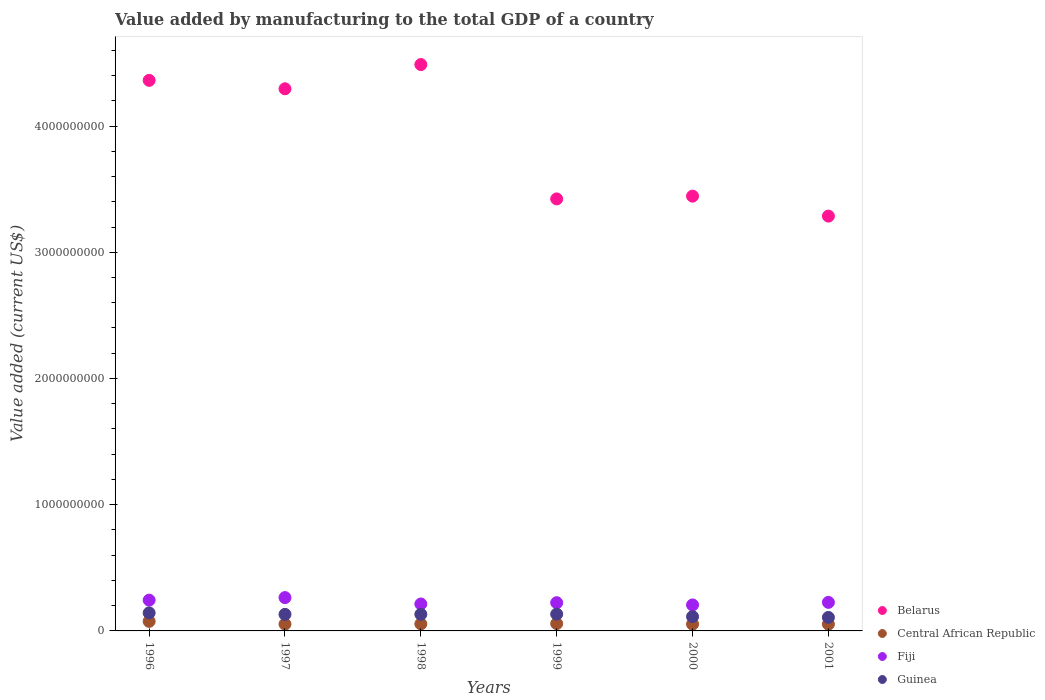Is the number of dotlines equal to the number of legend labels?
Keep it short and to the point. Yes. What is the value added by manufacturing to the total GDP in Guinea in 1998?
Offer a terse response. 1.32e+08. Across all years, what is the maximum value added by manufacturing to the total GDP in Central African Republic?
Your answer should be compact. 7.56e+07. Across all years, what is the minimum value added by manufacturing to the total GDP in Guinea?
Provide a succinct answer. 1.07e+08. What is the total value added by manufacturing to the total GDP in Central African Republic in the graph?
Offer a terse response. 3.50e+08. What is the difference between the value added by manufacturing to the total GDP in Fiji in 2000 and that in 2001?
Offer a terse response. -2.03e+07. What is the difference between the value added by manufacturing to the total GDP in Central African Republic in 1997 and the value added by manufacturing to the total GDP in Fiji in 1996?
Make the answer very short. -1.90e+08. What is the average value added by manufacturing to the total GDP in Belarus per year?
Make the answer very short. 3.88e+09. In the year 1998, what is the difference between the value added by manufacturing to the total GDP in Fiji and value added by manufacturing to the total GDP in Guinea?
Make the answer very short. 8.17e+07. What is the ratio of the value added by manufacturing to the total GDP in Fiji in 1999 to that in 2001?
Give a very brief answer. 0.99. What is the difference between the highest and the second highest value added by manufacturing to the total GDP in Guinea?
Offer a very short reply. 9.81e+06. What is the difference between the highest and the lowest value added by manufacturing to the total GDP in Central African Republic?
Ensure brevity in your answer.  2.22e+07. In how many years, is the value added by manufacturing to the total GDP in Belarus greater than the average value added by manufacturing to the total GDP in Belarus taken over all years?
Make the answer very short. 3. Is it the case that in every year, the sum of the value added by manufacturing to the total GDP in Central African Republic and value added by manufacturing to the total GDP in Belarus  is greater than the value added by manufacturing to the total GDP in Guinea?
Keep it short and to the point. Yes. Does the value added by manufacturing to the total GDP in Guinea monotonically increase over the years?
Your response must be concise. No. Is the value added by manufacturing to the total GDP in Belarus strictly greater than the value added by manufacturing to the total GDP in Central African Republic over the years?
Provide a succinct answer. Yes. How many years are there in the graph?
Your answer should be very brief. 6. Does the graph contain any zero values?
Give a very brief answer. No. Does the graph contain grids?
Keep it short and to the point. No. How are the legend labels stacked?
Offer a terse response. Vertical. What is the title of the graph?
Your response must be concise. Value added by manufacturing to the total GDP of a country. Does "New Caledonia" appear as one of the legend labels in the graph?
Keep it short and to the point. No. What is the label or title of the Y-axis?
Give a very brief answer. Value added (current US$). What is the Value added (current US$) of Belarus in 1996?
Your answer should be compact. 4.36e+09. What is the Value added (current US$) in Central African Republic in 1996?
Your answer should be very brief. 7.56e+07. What is the Value added (current US$) of Fiji in 1996?
Provide a succinct answer. 2.44e+08. What is the Value added (current US$) in Guinea in 1996?
Your answer should be compact. 1.43e+08. What is the Value added (current US$) of Belarus in 1997?
Ensure brevity in your answer.  4.29e+09. What is the Value added (current US$) of Central African Republic in 1997?
Offer a terse response. 5.36e+07. What is the Value added (current US$) of Fiji in 1997?
Provide a succinct answer. 2.64e+08. What is the Value added (current US$) of Guinea in 1997?
Give a very brief answer. 1.31e+08. What is the Value added (current US$) in Belarus in 1998?
Your response must be concise. 4.49e+09. What is the Value added (current US$) in Central African Republic in 1998?
Provide a succinct answer. 5.57e+07. What is the Value added (current US$) in Fiji in 1998?
Make the answer very short. 2.13e+08. What is the Value added (current US$) of Guinea in 1998?
Provide a succinct answer. 1.32e+08. What is the Value added (current US$) of Belarus in 1999?
Keep it short and to the point. 3.42e+09. What is the Value added (current US$) in Central African Republic in 1999?
Provide a short and direct response. 5.80e+07. What is the Value added (current US$) in Fiji in 1999?
Provide a short and direct response. 2.24e+08. What is the Value added (current US$) of Guinea in 1999?
Offer a terse response. 1.33e+08. What is the Value added (current US$) in Belarus in 2000?
Offer a very short reply. 3.44e+09. What is the Value added (current US$) in Central African Republic in 2000?
Your response must be concise. 5.35e+07. What is the Value added (current US$) of Fiji in 2000?
Your answer should be very brief. 2.06e+08. What is the Value added (current US$) of Guinea in 2000?
Provide a succinct answer. 1.13e+08. What is the Value added (current US$) of Belarus in 2001?
Your response must be concise. 3.29e+09. What is the Value added (current US$) in Central African Republic in 2001?
Give a very brief answer. 5.34e+07. What is the Value added (current US$) of Fiji in 2001?
Offer a very short reply. 2.26e+08. What is the Value added (current US$) of Guinea in 2001?
Provide a succinct answer. 1.07e+08. Across all years, what is the maximum Value added (current US$) in Belarus?
Provide a succinct answer. 4.49e+09. Across all years, what is the maximum Value added (current US$) of Central African Republic?
Provide a succinct answer. 7.56e+07. Across all years, what is the maximum Value added (current US$) of Fiji?
Your answer should be compact. 2.64e+08. Across all years, what is the maximum Value added (current US$) in Guinea?
Provide a succinct answer. 1.43e+08. Across all years, what is the minimum Value added (current US$) of Belarus?
Offer a very short reply. 3.29e+09. Across all years, what is the minimum Value added (current US$) in Central African Republic?
Provide a succinct answer. 5.34e+07. Across all years, what is the minimum Value added (current US$) in Fiji?
Give a very brief answer. 2.06e+08. Across all years, what is the minimum Value added (current US$) in Guinea?
Your answer should be very brief. 1.07e+08. What is the total Value added (current US$) of Belarus in the graph?
Offer a very short reply. 2.33e+1. What is the total Value added (current US$) in Central African Republic in the graph?
Your answer should be compact. 3.50e+08. What is the total Value added (current US$) in Fiji in the graph?
Provide a short and direct response. 1.38e+09. What is the total Value added (current US$) in Guinea in the graph?
Provide a short and direct response. 7.59e+08. What is the difference between the Value added (current US$) in Belarus in 1996 and that in 1997?
Your response must be concise. 6.69e+07. What is the difference between the Value added (current US$) of Central African Republic in 1996 and that in 1997?
Give a very brief answer. 2.20e+07. What is the difference between the Value added (current US$) in Fiji in 1996 and that in 1997?
Keep it short and to the point. -2.00e+07. What is the difference between the Value added (current US$) in Guinea in 1996 and that in 1997?
Your answer should be very brief. 1.18e+07. What is the difference between the Value added (current US$) in Belarus in 1996 and that in 1998?
Offer a terse response. -1.25e+08. What is the difference between the Value added (current US$) of Central African Republic in 1996 and that in 1998?
Make the answer very short. 1.99e+07. What is the difference between the Value added (current US$) of Fiji in 1996 and that in 1998?
Your answer should be very brief. 3.05e+07. What is the difference between the Value added (current US$) of Guinea in 1996 and that in 1998?
Offer a very short reply. 1.12e+07. What is the difference between the Value added (current US$) of Belarus in 1996 and that in 1999?
Ensure brevity in your answer.  9.39e+08. What is the difference between the Value added (current US$) of Central African Republic in 1996 and that in 1999?
Your answer should be compact. 1.76e+07. What is the difference between the Value added (current US$) of Fiji in 1996 and that in 1999?
Offer a terse response. 2.04e+07. What is the difference between the Value added (current US$) in Guinea in 1996 and that in 1999?
Your answer should be compact. 9.81e+06. What is the difference between the Value added (current US$) in Belarus in 1996 and that in 2000?
Your answer should be compact. 9.17e+08. What is the difference between the Value added (current US$) in Central African Republic in 1996 and that in 2000?
Ensure brevity in your answer.  2.21e+07. What is the difference between the Value added (current US$) of Fiji in 1996 and that in 2000?
Keep it short and to the point. 3.80e+07. What is the difference between the Value added (current US$) of Guinea in 1996 and that in 2000?
Offer a very short reply. 2.98e+07. What is the difference between the Value added (current US$) in Belarus in 1996 and that in 2001?
Make the answer very short. 1.08e+09. What is the difference between the Value added (current US$) in Central African Republic in 1996 and that in 2001?
Your response must be concise. 2.22e+07. What is the difference between the Value added (current US$) in Fiji in 1996 and that in 2001?
Your answer should be compact. 1.77e+07. What is the difference between the Value added (current US$) of Guinea in 1996 and that in 2001?
Provide a succinct answer. 3.59e+07. What is the difference between the Value added (current US$) of Belarus in 1997 and that in 1998?
Keep it short and to the point. -1.92e+08. What is the difference between the Value added (current US$) of Central African Republic in 1997 and that in 1998?
Keep it short and to the point. -2.15e+06. What is the difference between the Value added (current US$) in Fiji in 1997 and that in 1998?
Your response must be concise. 5.06e+07. What is the difference between the Value added (current US$) of Guinea in 1997 and that in 1998?
Ensure brevity in your answer.  -5.29e+05. What is the difference between the Value added (current US$) of Belarus in 1997 and that in 1999?
Your answer should be very brief. 8.72e+08. What is the difference between the Value added (current US$) of Central African Republic in 1997 and that in 1999?
Keep it short and to the point. -4.45e+06. What is the difference between the Value added (current US$) in Fiji in 1997 and that in 1999?
Keep it short and to the point. 4.04e+07. What is the difference between the Value added (current US$) of Guinea in 1997 and that in 1999?
Make the answer very short. -1.94e+06. What is the difference between the Value added (current US$) of Belarus in 1997 and that in 2000?
Keep it short and to the point. 8.50e+08. What is the difference between the Value added (current US$) of Central African Republic in 1997 and that in 2000?
Provide a short and direct response. 2.63e+04. What is the difference between the Value added (current US$) in Fiji in 1997 and that in 2000?
Give a very brief answer. 5.80e+07. What is the difference between the Value added (current US$) in Guinea in 1997 and that in 2000?
Provide a short and direct response. 1.80e+07. What is the difference between the Value added (current US$) of Belarus in 1997 and that in 2001?
Give a very brief answer. 1.01e+09. What is the difference between the Value added (current US$) in Central African Republic in 1997 and that in 2001?
Your response must be concise. 1.63e+05. What is the difference between the Value added (current US$) in Fiji in 1997 and that in 2001?
Offer a very short reply. 3.77e+07. What is the difference between the Value added (current US$) in Guinea in 1997 and that in 2001?
Make the answer very short. 2.41e+07. What is the difference between the Value added (current US$) of Belarus in 1998 and that in 1999?
Offer a very short reply. 1.06e+09. What is the difference between the Value added (current US$) in Central African Republic in 1998 and that in 1999?
Your answer should be very brief. -2.30e+06. What is the difference between the Value added (current US$) of Fiji in 1998 and that in 1999?
Offer a very short reply. -1.01e+07. What is the difference between the Value added (current US$) in Guinea in 1998 and that in 1999?
Offer a terse response. -1.41e+06. What is the difference between the Value added (current US$) in Belarus in 1998 and that in 2000?
Make the answer very short. 1.04e+09. What is the difference between the Value added (current US$) of Central African Republic in 1998 and that in 2000?
Offer a very short reply. 2.18e+06. What is the difference between the Value added (current US$) in Fiji in 1998 and that in 2000?
Offer a terse response. 7.43e+06. What is the difference between the Value added (current US$) in Guinea in 1998 and that in 2000?
Keep it short and to the point. 1.86e+07. What is the difference between the Value added (current US$) in Belarus in 1998 and that in 2001?
Your answer should be compact. 1.20e+09. What is the difference between the Value added (current US$) of Central African Republic in 1998 and that in 2001?
Offer a very short reply. 2.31e+06. What is the difference between the Value added (current US$) in Fiji in 1998 and that in 2001?
Your answer should be very brief. -1.28e+07. What is the difference between the Value added (current US$) in Guinea in 1998 and that in 2001?
Ensure brevity in your answer.  2.47e+07. What is the difference between the Value added (current US$) in Belarus in 1999 and that in 2000?
Offer a very short reply. -2.19e+07. What is the difference between the Value added (current US$) of Central African Republic in 1999 and that in 2000?
Offer a very short reply. 4.48e+06. What is the difference between the Value added (current US$) of Fiji in 1999 and that in 2000?
Ensure brevity in your answer.  1.76e+07. What is the difference between the Value added (current US$) of Guinea in 1999 and that in 2000?
Keep it short and to the point. 2.00e+07. What is the difference between the Value added (current US$) in Belarus in 1999 and that in 2001?
Provide a short and direct response. 1.36e+08. What is the difference between the Value added (current US$) of Central African Republic in 1999 and that in 2001?
Offer a very short reply. 4.62e+06. What is the difference between the Value added (current US$) in Fiji in 1999 and that in 2001?
Give a very brief answer. -2.69e+06. What is the difference between the Value added (current US$) of Guinea in 1999 and that in 2001?
Your response must be concise. 2.61e+07. What is the difference between the Value added (current US$) in Belarus in 2000 and that in 2001?
Your answer should be very brief. 1.58e+08. What is the difference between the Value added (current US$) of Central African Republic in 2000 and that in 2001?
Keep it short and to the point. 1.36e+05. What is the difference between the Value added (current US$) of Fiji in 2000 and that in 2001?
Make the answer very short. -2.03e+07. What is the difference between the Value added (current US$) of Guinea in 2000 and that in 2001?
Keep it short and to the point. 6.09e+06. What is the difference between the Value added (current US$) of Belarus in 1996 and the Value added (current US$) of Central African Republic in 1997?
Your answer should be very brief. 4.31e+09. What is the difference between the Value added (current US$) of Belarus in 1996 and the Value added (current US$) of Fiji in 1997?
Your response must be concise. 4.10e+09. What is the difference between the Value added (current US$) in Belarus in 1996 and the Value added (current US$) in Guinea in 1997?
Offer a very short reply. 4.23e+09. What is the difference between the Value added (current US$) of Central African Republic in 1996 and the Value added (current US$) of Fiji in 1997?
Provide a short and direct response. -1.88e+08. What is the difference between the Value added (current US$) in Central African Republic in 1996 and the Value added (current US$) in Guinea in 1997?
Provide a succinct answer. -5.55e+07. What is the difference between the Value added (current US$) of Fiji in 1996 and the Value added (current US$) of Guinea in 1997?
Offer a very short reply. 1.13e+08. What is the difference between the Value added (current US$) in Belarus in 1996 and the Value added (current US$) in Central African Republic in 1998?
Offer a terse response. 4.31e+09. What is the difference between the Value added (current US$) of Belarus in 1996 and the Value added (current US$) of Fiji in 1998?
Offer a terse response. 4.15e+09. What is the difference between the Value added (current US$) in Belarus in 1996 and the Value added (current US$) in Guinea in 1998?
Your response must be concise. 4.23e+09. What is the difference between the Value added (current US$) of Central African Republic in 1996 and the Value added (current US$) of Fiji in 1998?
Give a very brief answer. -1.38e+08. What is the difference between the Value added (current US$) in Central African Republic in 1996 and the Value added (current US$) in Guinea in 1998?
Give a very brief answer. -5.61e+07. What is the difference between the Value added (current US$) in Fiji in 1996 and the Value added (current US$) in Guinea in 1998?
Keep it short and to the point. 1.12e+08. What is the difference between the Value added (current US$) in Belarus in 1996 and the Value added (current US$) in Central African Republic in 1999?
Your answer should be compact. 4.30e+09. What is the difference between the Value added (current US$) in Belarus in 1996 and the Value added (current US$) in Fiji in 1999?
Your answer should be compact. 4.14e+09. What is the difference between the Value added (current US$) in Belarus in 1996 and the Value added (current US$) in Guinea in 1999?
Provide a short and direct response. 4.23e+09. What is the difference between the Value added (current US$) in Central African Republic in 1996 and the Value added (current US$) in Fiji in 1999?
Offer a terse response. -1.48e+08. What is the difference between the Value added (current US$) of Central African Republic in 1996 and the Value added (current US$) of Guinea in 1999?
Provide a succinct answer. -5.75e+07. What is the difference between the Value added (current US$) in Fiji in 1996 and the Value added (current US$) in Guinea in 1999?
Keep it short and to the point. 1.11e+08. What is the difference between the Value added (current US$) in Belarus in 1996 and the Value added (current US$) in Central African Republic in 2000?
Offer a very short reply. 4.31e+09. What is the difference between the Value added (current US$) in Belarus in 1996 and the Value added (current US$) in Fiji in 2000?
Provide a short and direct response. 4.16e+09. What is the difference between the Value added (current US$) of Belarus in 1996 and the Value added (current US$) of Guinea in 2000?
Keep it short and to the point. 4.25e+09. What is the difference between the Value added (current US$) of Central African Republic in 1996 and the Value added (current US$) of Fiji in 2000?
Ensure brevity in your answer.  -1.30e+08. What is the difference between the Value added (current US$) in Central African Republic in 1996 and the Value added (current US$) in Guinea in 2000?
Your answer should be very brief. -3.75e+07. What is the difference between the Value added (current US$) of Fiji in 1996 and the Value added (current US$) of Guinea in 2000?
Your answer should be compact. 1.31e+08. What is the difference between the Value added (current US$) of Belarus in 1996 and the Value added (current US$) of Central African Republic in 2001?
Ensure brevity in your answer.  4.31e+09. What is the difference between the Value added (current US$) in Belarus in 1996 and the Value added (current US$) in Fiji in 2001?
Your answer should be very brief. 4.14e+09. What is the difference between the Value added (current US$) of Belarus in 1996 and the Value added (current US$) of Guinea in 2001?
Provide a succinct answer. 4.25e+09. What is the difference between the Value added (current US$) of Central African Republic in 1996 and the Value added (current US$) of Fiji in 2001?
Offer a very short reply. -1.51e+08. What is the difference between the Value added (current US$) in Central African Republic in 1996 and the Value added (current US$) in Guinea in 2001?
Make the answer very short. -3.14e+07. What is the difference between the Value added (current US$) of Fiji in 1996 and the Value added (current US$) of Guinea in 2001?
Keep it short and to the point. 1.37e+08. What is the difference between the Value added (current US$) of Belarus in 1997 and the Value added (current US$) of Central African Republic in 1998?
Ensure brevity in your answer.  4.24e+09. What is the difference between the Value added (current US$) of Belarus in 1997 and the Value added (current US$) of Fiji in 1998?
Offer a very short reply. 4.08e+09. What is the difference between the Value added (current US$) of Belarus in 1997 and the Value added (current US$) of Guinea in 1998?
Ensure brevity in your answer.  4.16e+09. What is the difference between the Value added (current US$) of Central African Republic in 1997 and the Value added (current US$) of Fiji in 1998?
Give a very brief answer. -1.60e+08. What is the difference between the Value added (current US$) in Central African Republic in 1997 and the Value added (current US$) in Guinea in 1998?
Your response must be concise. -7.81e+07. What is the difference between the Value added (current US$) of Fiji in 1997 and the Value added (current US$) of Guinea in 1998?
Offer a terse response. 1.32e+08. What is the difference between the Value added (current US$) in Belarus in 1997 and the Value added (current US$) in Central African Republic in 1999?
Your answer should be compact. 4.24e+09. What is the difference between the Value added (current US$) of Belarus in 1997 and the Value added (current US$) of Fiji in 1999?
Your response must be concise. 4.07e+09. What is the difference between the Value added (current US$) of Belarus in 1997 and the Value added (current US$) of Guinea in 1999?
Offer a very short reply. 4.16e+09. What is the difference between the Value added (current US$) of Central African Republic in 1997 and the Value added (current US$) of Fiji in 1999?
Make the answer very short. -1.70e+08. What is the difference between the Value added (current US$) of Central African Republic in 1997 and the Value added (current US$) of Guinea in 1999?
Give a very brief answer. -7.95e+07. What is the difference between the Value added (current US$) of Fiji in 1997 and the Value added (current US$) of Guinea in 1999?
Ensure brevity in your answer.  1.31e+08. What is the difference between the Value added (current US$) in Belarus in 1997 and the Value added (current US$) in Central African Republic in 2000?
Your answer should be very brief. 4.24e+09. What is the difference between the Value added (current US$) of Belarus in 1997 and the Value added (current US$) of Fiji in 2000?
Offer a very short reply. 4.09e+09. What is the difference between the Value added (current US$) in Belarus in 1997 and the Value added (current US$) in Guinea in 2000?
Keep it short and to the point. 4.18e+09. What is the difference between the Value added (current US$) of Central African Republic in 1997 and the Value added (current US$) of Fiji in 2000?
Your answer should be compact. -1.52e+08. What is the difference between the Value added (current US$) of Central African Republic in 1997 and the Value added (current US$) of Guinea in 2000?
Offer a terse response. -5.95e+07. What is the difference between the Value added (current US$) of Fiji in 1997 and the Value added (current US$) of Guinea in 2000?
Ensure brevity in your answer.  1.51e+08. What is the difference between the Value added (current US$) of Belarus in 1997 and the Value added (current US$) of Central African Republic in 2001?
Offer a very short reply. 4.24e+09. What is the difference between the Value added (current US$) of Belarus in 1997 and the Value added (current US$) of Fiji in 2001?
Keep it short and to the point. 4.07e+09. What is the difference between the Value added (current US$) of Belarus in 1997 and the Value added (current US$) of Guinea in 2001?
Offer a very short reply. 4.19e+09. What is the difference between the Value added (current US$) in Central African Republic in 1997 and the Value added (current US$) in Fiji in 2001?
Offer a very short reply. -1.73e+08. What is the difference between the Value added (current US$) in Central African Republic in 1997 and the Value added (current US$) in Guinea in 2001?
Your answer should be very brief. -5.34e+07. What is the difference between the Value added (current US$) in Fiji in 1997 and the Value added (current US$) in Guinea in 2001?
Your response must be concise. 1.57e+08. What is the difference between the Value added (current US$) of Belarus in 1998 and the Value added (current US$) of Central African Republic in 1999?
Make the answer very short. 4.43e+09. What is the difference between the Value added (current US$) of Belarus in 1998 and the Value added (current US$) of Fiji in 1999?
Give a very brief answer. 4.26e+09. What is the difference between the Value added (current US$) in Belarus in 1998 and the Value added (current US$) in Guinea in 1999?
Make the answer very short. 4.35e+09. What is the difference between the Value added (current US$) of Central African Republic in 1998 and the Value added (current US$) of Fiji in 1999?
Make the answer very short. -1.68e+08. What is the difference between the Value added (current US$) of Central African Republic in 1998 and the Value added (current US$) of Guinea in 1999?
Offer a very short reply. -7.73e+07. What is the difference between the Value added (current US$) in Fiji in 1998 and the Value added (current US$) in Guinea in 1999?
Provide a short and direct response. 8.03e+07. What is the difference between the Value added (current US$) in Belarus in 1998 and the Value added (current US$) in Central African Republic in 2000?
Offer a very short reply. 4.43e+09. What is the difference between the Value added (current US$) of Belarus in 1998 and the Value added (current US$) of Fiji in 2000?
Give a very brief answer. 4.28e+09. What is the difference between the Value added (current US$) in Belarus in 1998 and the Value added (current US$) in Guinea in 2000?
Make the answer very short. 4.37e+09. What is the difference between the Value added (current US$) in Central African Republic in 1998 and the Value added (current US$) in Fiji in 2000?
Ensure brevity in your answer.  -1.50e+08. What is the difference between the Value added (current US$) of Central African Republic in 1998 and the Value added (current US$) of Guinea in 2000?
Make the answer very short. -5.74e+07. What is the difference between the Value added (current US$) in Fiji in 1998 and the Value added (current US$) in Guinea in 2000?
Ensure brevity in your answer.  1.00e+08. What is the difference between the Value added (current US$) of Belarus in 1998 and the Value added (current US$) of Central African Republic in 2001?
Keep it short and to the point. 4.43e+09. What is the difference between the Value added (current US$) of Belarus in 1998 and the Value added (current US$) of Fiji in 2001?
Provide a short and direct response. 4.26e+09. What is the difference between the Value added (current US$) of Belarus in 1998 and the Value added (current US$) of Guinea in 2001?
Offer a terse response. 4.38e+09. What is the difference between the Value added (current US$) in Central African Republic in 1998 and the Value added (current US$) in Fiji in 2001?
Provide a short and direct response. -1.71e+08. What is the difference between the Value added (current US$) in Central African Republic in 1998 and the Value added (current US$) in Guinea in 2001?
Keep it short and to the point. -5.13e+07. What is the difference between the Value added (current US$) in Fiji in 1998 and the Value added (current US$) in Guinea in 2001?
Make the answer very short. 1.06e+08. What is the difference between the Value added (current US$) of Belarus in 1999 and the Value added (current US$) of Central African Republic in 2000?
Your response must be concise. 3.37e+09. What is the difference between the Value added (current US$) in Belarus in 1999 and the Value added (current US$) in Fiji in 2000?
Give a very brief answer. 3.22e+09. What is the difference between the Value added (current US$) of Belarus in 1999 and the Value added (current US$) of Guinea in 2000?
Keep it short and to the point. 3.31e+09. What is the difference between the Value added (current US$) of Central African Republic in 1999 and the Value added (current US$) of Fiji in 2000?
Ensure brevity in your answer.  -1.48e+08. What is the difference between the Value added (current US$) in Central African Republic in 1999 and the Value added (current US$) in Guinea in 2000?
Make the answer very short. -5.51e+07. What is the difference between the Value added (current US$) in Fiji in 1999 and the Value added (current US$) in Guinea in 2000?
Offer a terse response. 1.10e+08. What is the difference between the Value added (current US$) of Belarus in 1999 and the Value added (current US$) of Central African Republic in 2001?
Keep it short and to the point. 3.37e+09. What is the difference between the Value added (current US$) in Belarus in 1999 and the Value added (current US$) in Fiji in 2001?
Your answer should be very brief. 3.20e+09. What is the difference between the Value added (current US$) of Belarus in 1999 and the Value added (current US$) of Guinea in 2001?
Offer a terse response. 3.32e+09. What is the difference between the Value added (current US$) in Central African Republic in 1999 and the Value added (current US$) in Fiji in 2001?
Offer a very short reply. -1.68e+08. What is the difference between the Value added (current US$) in Central African Republic in 1999 and the Value added (current US$) in Guinea in 2001?
Offer a very short reply. -4.90e+07. What is the difference between the Value added (current US$) in Fiji in 1999 and the Value added (current US$) in Guinea in 2001?
Give a very brief answer. 1.17e+08. What is the difference between the Value added (current US$) of Belarus in 2000 and the Value added (current US$) of Central African Republic in 2001?
Make the answer very short. 3.39e+09. What is the difference between the Value added (current US$) in Belarus in 2000 and the Value added (current US$) in Fiji in 2001?
Give a very brief answer. 3.22e+09. What is the difference between the Value added (current US$) of Belarus in 2000 and the Value added (current US$) of Guinea in 2001?
Provide a succinct answer. 3.34e+09. What is the difference between the Value added (current US$) of Central African Republic in 2000 and the Value added (current US$) of Fiji in 2001?
Your answer should be compact. -1.73e+08. What is the difference between the Value added (current US$) in Central African Republic in 2000 and the Value added (current US$) in Guinea in 2001?
Make the answer very short. -5.35e+07. What is the difference between the Value added (current US$) in Fiji in 2000 and the Value added (current US$) in Guinea in 2001?
Your answer should be very brief. 9.90e+07. What is the average Value added (current US$) of Belarus per year?
Your answer should be compact. 3.88e+09. What is the average Value added (current US$) of Central African Republic per year?
Ensure brevity in your answer.  5.83e+07. What is the average Value added (current US$) of Fiji per year?
Make the answer very short. 2.30e+08. What is the average Value added (current US$) in Guinea per year?
Make the answer very short. 1.26e+08. In the year 1996, what is the difference between the Value added (current US$) in Belarus and Value added (current US$) in Central African Republic?
Give a very brief answer. 4.29e+09. In the year 1996, what is the difference between the Value added (current US$) of Belarus and Value added (current US$) of Fiji?
Give a very brief answer. 4.12e+09. In the year 1996, what is the difference between the Value added (current US$) in Belarus and Value added (current US$) in Guinea?
Ensure brevity in your answer.  4.22e+09. In the year 1996, what is the difference between the Value added (current US$) of Central African Republic and Value added (current US$) of Fiji?
Your answer should be very brief. -1.68e+08. In the year 1996, what is the difference between the Value added (current US$) in Central African Republic and Value added (current US$) in Guinea?
Offer a very short reply. -6.73e+07. In the year 1996, what is the difference between the Value added (current US$) in Fiji and Value added (current US$) in Guinea?
Your answer should be very brief. 1.01e+08. In the year 1997, what is the difference between the Value added (current US$) of Belarus and Value added (current US$) of Central African Republic?
Ensure brevity in your answer.  4.24e+09. In the year 1997, what is the difference between the Value added (current US$) of Belarus and Value added (current US$) of Fiji?
Offer a very short reply. 4.03e+09. In the year 1997, what is the difference between the Value added (current US$) in Belarus and Value added (current US$) in Guinea?
Offer a very short reply. 4.16e+09. In the year 1997, what is the difference between the Value added (current US$) of Central African Republic and Value added (current US$) of Fiji?
Your answer should be compact. -2.10e+08. In the year 1997, what is the difference between the Value added (current US$) in Central African Republic and Value added (current US$) in Guinea?
Your answer should be compact. -7.76e+07. In the year 1997, what is the difference between the Value added (current US$) in Fiji and Value added (current US$) in Guinea?
Make the answer very short. 1.33e+08. In the year 1998, what is the difference between the Value added (current US$) in Belarus and Value added (current US$) in Central African Republic?
Your answer should be compact. 4.43e+09. In the year 1998, what is the difference between the Value added (current US$) of Belarus and Value added (current US$) of Fiji?
Your response must be concise. 4.27e+09. In the year 1998, what is the difference between the Value added (current US$) in Belarus and Value added (current US$) in Guinea?
Ensure brevity in your answer.  4.36e+09. In the year 1998, what is the difference between the Value added (current US$) in Central African Republic and Value added (current US$) in Fiji?
Ensure brevity in your answer.  -1.58e+08. In the year 1998, what is the difference between the Value added (current US$) in Central African Republic and Value added (current US$) in Guinea?
Your answer should be very brief. -7.59e+07. In the year 1998, what is the difference between the Value added (current US$) in Fiji and Value added (current US$) in Guinea?
Give a very brief answer. 8.17e+07. In the year 1999, what is the difference between the Value added (current US$) in Belarus and Value added (current US$) in Central African Republic?
Your answer should be very brief. 3.36e+09. In the year 1999, what is the difference between the Value added (current US$) in Belarus and Value added (current US$) in Fiji?
Ensure brevity in your answer.  3.20e+09. In the year 1999, what is the difference between the Value added (current US$) of Belarus and Value added (current US$) of Guinea?
Ensure brevity in your answer.  3.29e+09. In the year 1999, what is the difference between the Value added (current US$) of Central African Republic and Value added (current US$) of Fiji?
Make the answer very short. -1.66e+08. In the year 1999, what is the difference between the Value added (current US$) in Central African Republic and Value added (current US$) in Guinea?
Your answer should be compact. -7.50e+07. In the year 1999, what is the difference between the Value added (current US$) of Fiji and Value added (current US$) of Guinea?
Your answer should be compact. 9.05e+07. In the year 2000, what is the difference between the Value added (current US$) of Belarus and Value added (current US$) of Central African Republic?
Ensure brevity in your answer.  3.39e+09. In the year 2000, what is the difference between the Value added (current US$) of Belarus and Value added (current US$) of Fiji?
Make the answer very short. 3.24e+09. In the year 2000, what is the difference between the Value added (current US$) of Belarus and Value added (current US$) of Guinea?
Give a very brief answer. 3.33e+09. In the year 2000, what is the difference between the Value added (current US$) in Central African Republic and Value added (current US$) in Fiji?
Give a very brief answer. -1.52e+08. In the year 2000, what is the difference between the Value added (current US$) in Central African Republic and Value added (current US$) in Guinea?
Your answer should be very brief. -5.95e+07. In the year 2000, what is the difference between the Value added (current US$) of Fiji and Value added (current US$) of Guinea?
Offer a very short reply. 9.29e+07. In the year 2001, what is the difference between the Value added (current US$) of Belarus and Value added (current US$) of Central African Republic?
Give a very brief answer. 3.23e+09. In the year 2001, what is the difference between the Value added (current US$) of Belarus and Value added (current US$) of Fiji?
Your response must be concise. 3.06e+09. In the year 2001, what is the difference between the Value added (current US$) in Belarus and Value added (current US$) in Guinea?
Ensure brevity in your answer.  3.18e+09. In the year 2001, what is the difference between the Value added (current US$) of Central African Republic and Value added (current US$) of Fiji?
Your answer should be compact. -1.73e+08. In the year 2001, what is the difference between the Value added (current US$) in Central African Republic and Value added (current US$) in Guinea?
Keep it short and to the point. -5.36e+07. In the year 2001, what is the difference between the Value added (current US$) of Fiji and Value added (current US$) of Guinea?
Your response must be concise. 1.19e+08. What is the ratio of the Value added (current US$) of Belarus in 1996 to that in 1997?
Provide a succinct answer. 1.02. What is the ratio of the Value added (current US$) in Central African Republic in 1996 to that in 1997?
Make the answer very short. 1.41. What is the ratio of the Value added (current US$) in Fiji in 1996 to that in 1997?
Offer a very short reply. 0.92. What is the ratio of the Value added (current US$) of Guinea in 1996 to that in 1997?
Keep it short and to the point. 1.09. What is the ratio of the Value added (current US$) of Belarus in 1996 to that in 1998?
Make the answer very short. 0.97. What is the ratio of the Value added (current US$) in Central African Republic in 1996 to that in 1998?
Offer a terse response. 1.36. What is the ratio of the Value added (current US$) of Fiji in 1996 to that in 1998?
Offer a terse response. 1.14. What is the ratio of the Value added (current US$) of Guinea in 1996 to that in 1998?
Provide a succinct answer. 1.09. What is the ratio of the Value added (current US$) of Belarus in 1996 to that in 1999?
Your answer should be compact. 1.27. What is the ratio of the Value added (current US$) of Central African Republic in 1996 to that in 1999?
Your answer should be compact. 1.3. What is the ratio of the Value added (current US$) of Fiji in 1996 to that in 1999?
Offer a very short reply. 1.09. What is the ratio of the Value added (current US$) of Guinea in 1996 to that in 1999?
Give a very brief answer. 1.07. What is the ratio of the Value added (current US$) in Belarus in 1996 to that in 2000?
Offer a very short reply. 1.27. What is the ratio of the Value added (current US$) in Central African Republic in 1996 to that in 2000?
Your answer should be very brief. 1.41. What is the ratio of the Value added (current US$) in Fiji in 1996 to that in 2000?
Provide a succinct answer. 1.18. What is the ratio of the Value added (current US$) in Guinea in 1996 to that in 2000?
Offer a terse response. 1.26. What is the ratio of the Value added (current US$) in Belarus in 1996 to that in 2001?
Give a very brief answer. 1.33. What is the ratio of the Value added (current US$) of Central African Republic in 1996 to that in 2001?
Make the answer very short. 1.42. What is the ratio of the Value added (current US$) of Fiji in 1996 to that in 2001?
Your answer should be compact. 1.08. What is the ratio of the Value added (current US$) of Guinea in 1996 to that in 2001?
Your answer should be compact. 1.34. What is the ratio of the Value added (current US$) of Belarus in 1997 to that in 1998?
Provide a succinct answer. 0.96. What is the ratio of the Value added (current US$) in Central African Republic in 1997 to that in 1998?
Provide a short and direct response. 0.96. What is the ratio of the Value added (current US$) of Fiji in 1997 to that in 1998?
Provide a succinct answer. 1.24. What is the ratio of the Value added (current US$) in Guinea in 1997 to that in 1998?
Provide a succinct answer. 1. What is the ratio of the Value added (current US$) in Belarus in 1997 to that in 1999?
Give a very brief answer. 1.25. What is the ratio of the Value added (current US$) in Central African Republic in 1997 to that in 1999?
Offer a terse response. 0.92. What is the ratio of the Value added (current US$) in Fiji in 1997 to that in 1999?
Your answer should be compact. 1.18. What is the ratio of the Value added (current US$) in Guinea in 1997 to that in 1999?
Ensure brevity in your answer.  0.99. What is the ratio of the Value added (current US$) in Belarus in 1997 to that in 2000?
Keep it short and to the point. 1.25. What is the ratio of the Value added (current US$) in Central African Republic in 1997 to that in 2000?
Give a very brief answer. 1. What is the ratio of the Value added (current US$) of Fiji in 1997 to that in 2000?
Your answer should be very brief. 1.28. What is the ratio of the Value added (current US$) in Guinea in 1997 to that in 2000?
Keep it short and to the point. 1.16. What is the ratio of the Value added (current US$) in Belarus in 1997 to that in 2001?
Provide a succinct answer. 1.31. What is the ratio of the Value added (current US$) in Fiji in 1997 to that in 2001?
Your answer should be very brief. 1.17. What is the ratio of the Value added (current US$) in Guinea in 1997 to that in 2001?
Make the answer very short. 1.23. What is the ratio of the Value added (current US$) in Belarus in 1998 to that in 1999?
Provide a short and direct response. 1.31. What is the ratio of the Value added (current US$) of Central African Republic in 1998 to that in 1999?
Offer a terse response. 0.96. What is the ratio of the Value added (current US$) in Fiji in 1998 to that in 1999?
Make the answer very short. 0.95. What is the ratio of the Value added (current US$) of Belarus in 1998 to that in 2000?
Provide a succinct answer. 1.3. What is the ratio of the Value added (current US$) in Central African Republic in 1998 to that in 2000?
Give a very brief answer. 1.04. What is the ratio of the Value added (current US$) in Fiji in 1998 to that in 2000?
Offer a very short reply. 1.04. What is the ratio of the Value added (current US$) in Guinea in 1998 to that in 2000?
Give a very brief answer. 1.16. What is the ratio of the Value added (current US$) of Belarus in 1998 to that in 2001?
Provide a succinct answer. 1.37. What is the ratio of the Value added (current US$) of Central African Republic in 1998 to that in 2001?
Provide a succinct answer. 1.04. What is the ratio of the Value added (current US$) in Fiji in 1998 to that in 2001?
Your response must be concise. 0.94. What is the ratio of the Value added (current US$) in Guinea in 1998 to that in 2001?
Ensure brevity in your answer.  1.23. What is the ratio of the Value added (current US$) in Belarus in 1999 to that in 2000?
Provide a succinct answer. 0.99. What is the ratio of the Value added (current US$) in Central African Republic in 1999 to that in 2000?
Your response must be concise. 1.08. What is the ratio of the Value added (current US$) in Fiji in 1999 to that in 2000?
Your response must be concise. 1.09. What is the ratio of the Value added (current US$) in Guinea in 1999 to that in 2000?
Provide a short and direct response. 1.18. What is the ratio of the Value added (current US$) of Belarus in 1999 to that in 2001?
Offer a terse response. 1.04. What is the ratio of the Value added (current US$) of Central African Republic in 1999 to that in 2001?
Your answer should be very brief. 1.09. What is the ratio of the Value added (current US$) of Guinea in 1999 to that in 2001?
Make the answer very short. 1.24. What is the ratio of the Value added (current US$) of Belarus in 2000 to that in 2001?
Your answer should be very brief. 1.05. What is the ratio of the Value added (current US$) in Central African Republic in 2000 to that in 2001?
Your answer should be compact. 1. What is the ratio of the Value added (current US$) of Fiji in 2000 to that in 2001?
Your answer should be compact. 0.91. What is the ratio of the Value added (current US$) in Guinea in 2000 to that in 2001?
Offer a very short reply. 1.06. What is the difference between the highest and the second highest Value added (current US$) in Belarus?
Offer a very short reply. 1.25e+08. What is the difference between the highest and the second highest Value added (current US$) in Central African Republic?
Provide a short and direct response. 1.76e+07. What is the difference between the highest and the second highest Value added (current US$) in Fiji?
Provide a succinct answer. 2.00e+07. What is the difference between the highest and the second highest Value added (current US$) of Guinea?
Keep it short and to the point. 9.81e+06. What is the difference between the highest and the lowest Value added (current US$) in Belarus?
Provide a short and direct response. 1.20e+09. What is the difference between the highest and the lowest Value added (current US$) of Central African Republic?
Your answer should be very brief. 2.22e+07. What is the difference between the highest and the lowest Value added (current US$) in Fiji?
Provide a short and direct response. 5.80e+07. What is the difference between the highest and the lowest Value added (current US$) of Guinea?
Provide a succinct answer. 3.59e+07. 